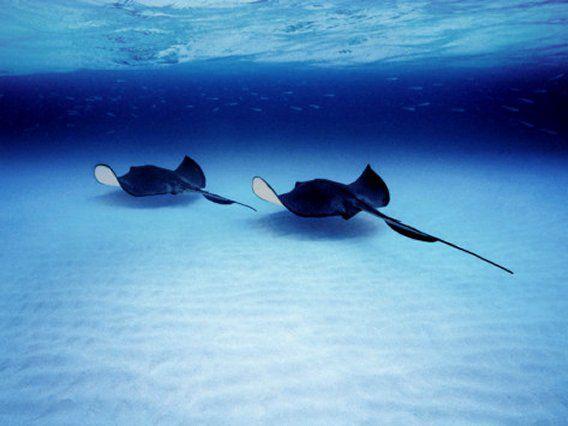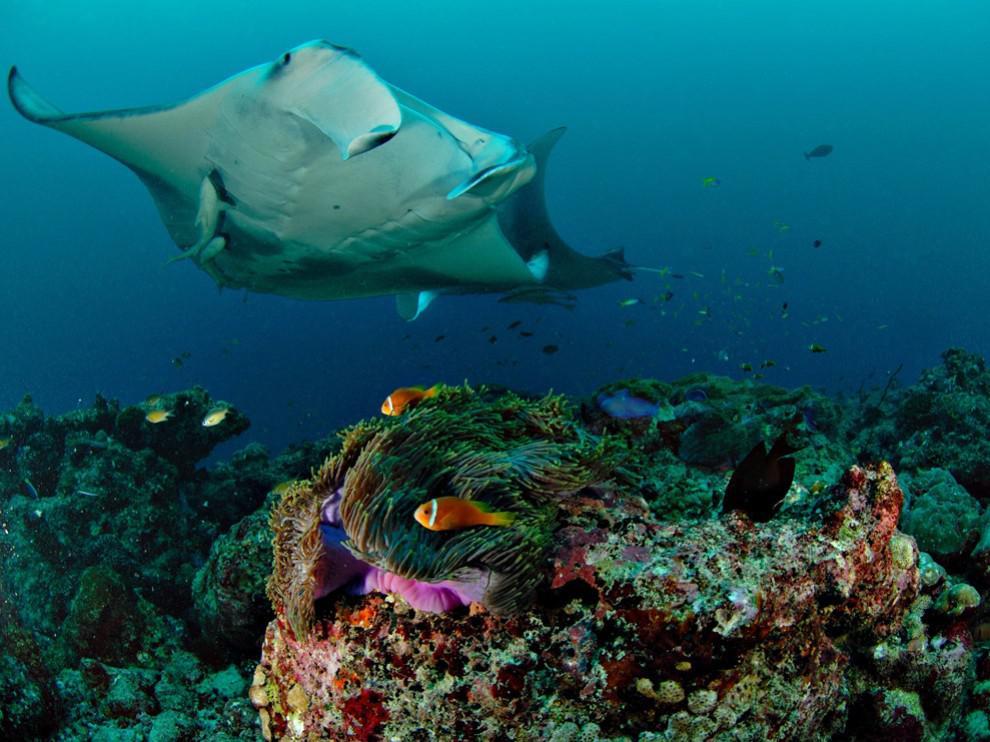The first image is the image on the left, the second image is the image on the right. Examine the images to the left and right. Is the description "There are at most 4 sting rays in one of the images." accurate? Answer yes or no. Yes. The first image is the image on the left, the second image is the image on the right. Given the left and right images, does the statement "At least one image contains no more than three stingray." hold true? Answer yes or no. Yes. 